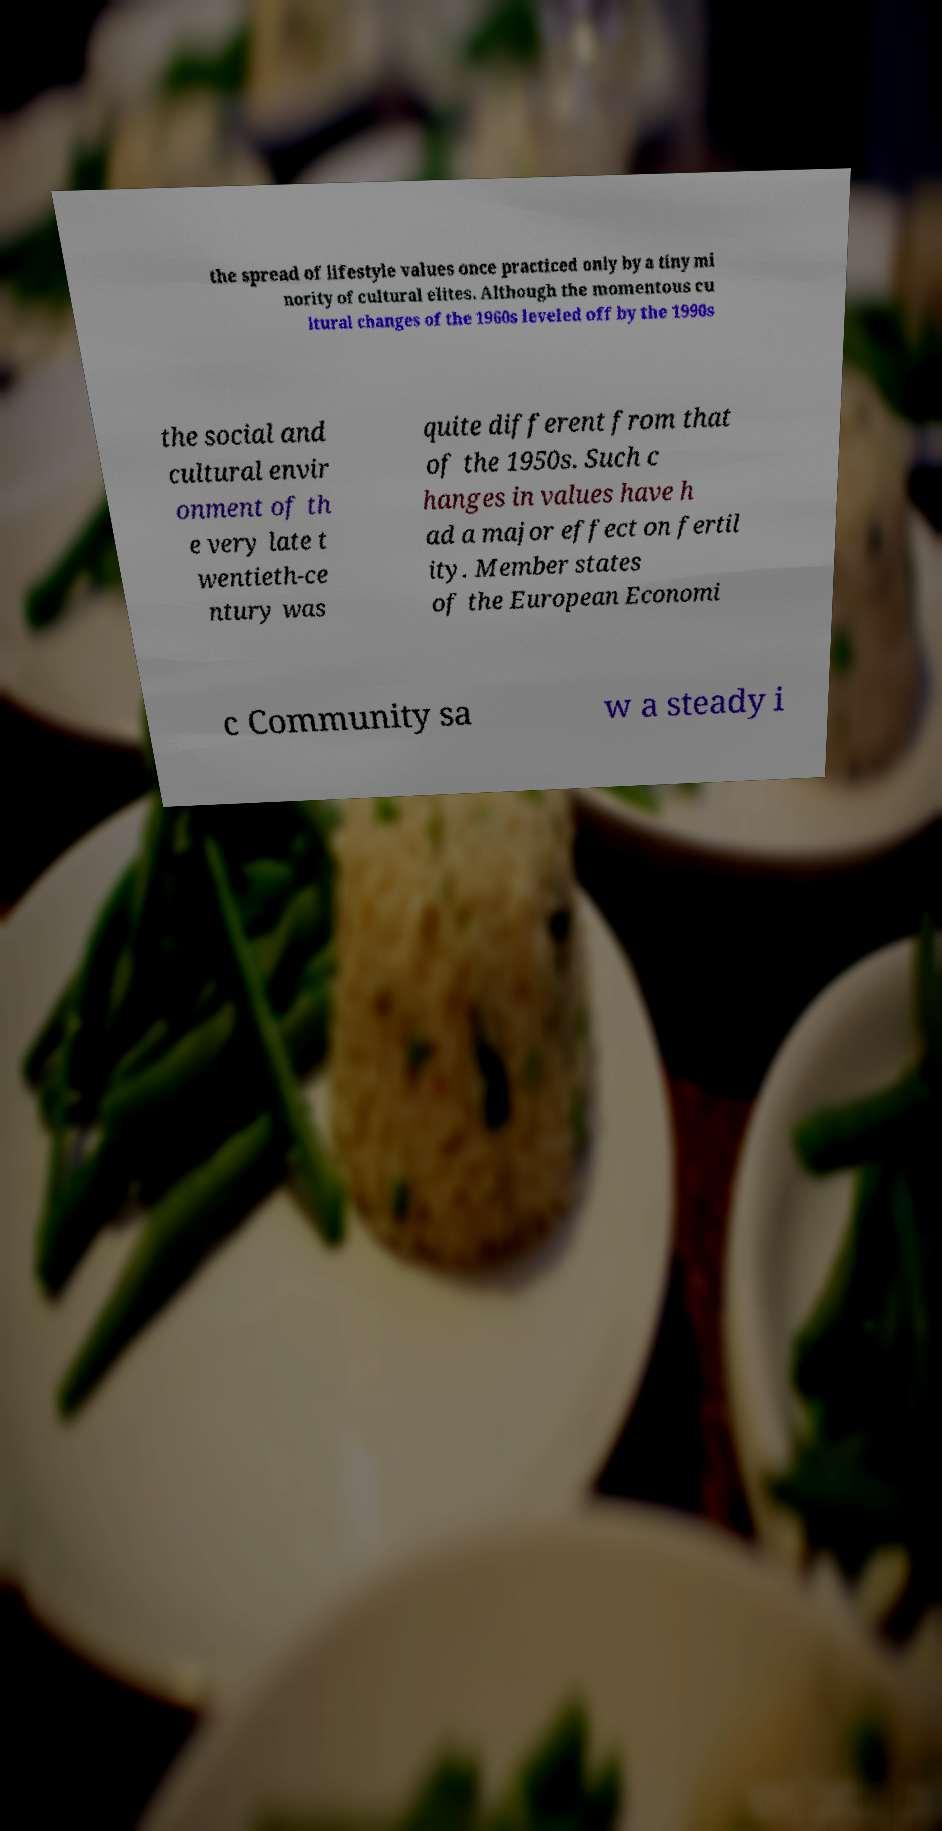Please identify and transcribe the text found in this image. the spread of lifestyle values once practiced only by a tiny mi nority of cultural elites. Although the momentous cu ltural changes of the 1960s leveled off by the 1990s the social and cultural envir onment of th e very late t wentieth-ce ntury was quite different from that of the 1950s. Such c hanges in values have h ad a major effect on fertil ity. Member states of the European Economi c Community sa w a steady i 